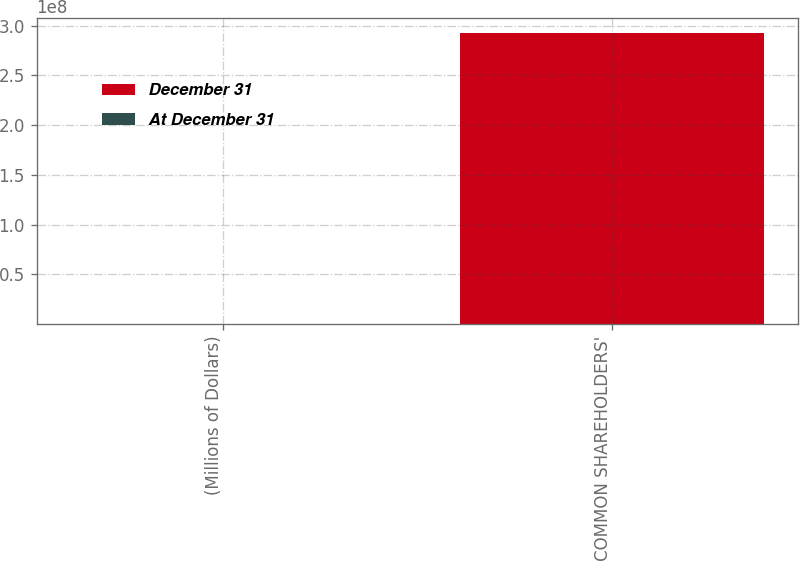<chart> <loc_0><loc_0><loc_500><loc_500><stacked_bar_chart><ecel><fcel>(Millions of Dollars)<fcel>TOTAL COMMON SHAREHOLDERS'<nl><fcel>December 31<fcel>2012<fcel>2.92872e+08<nl><fcel>At December 31<fcel>2012<fcel>11922<nl></chart> 